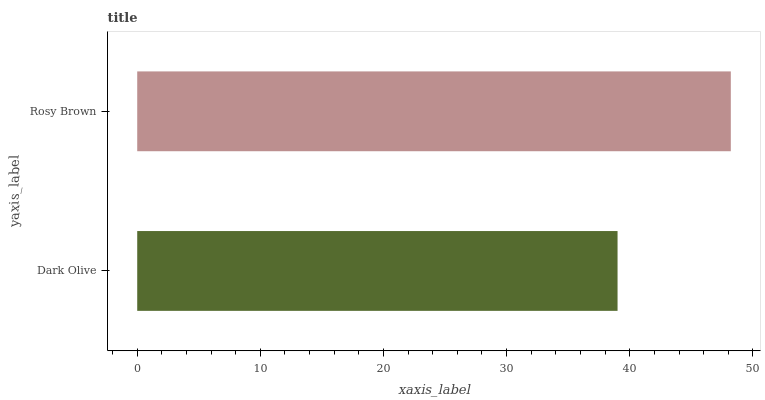Is Dark Olive the minimum?
Answer yes or no. Yes. Is Rosy Brown the maximum?
Answer yes or no. Yes. Is Rosy Brown the minimum?
Answer yes or no. No. Is Rosy Brown greater than Dark Olive?
Answer yes or no. Yes. Is Dark Olive less than Rosy Brown?
Answer yes or no. Yes. Is Dark Olive greater than Rosy Brown?
Answer yes or no. No. Is Rosy Brown less than Dark Olive?
Answer yes or no. No. Is Rosy Brown the high median?
Answer yes or no. Yes. Is Dark Olive the low median?
Answer yes or no. Yes. Is Dark Olive the high median?
Answer yes or no. No. Is Rosy Brown the low median?
Answer yes or no. No. 